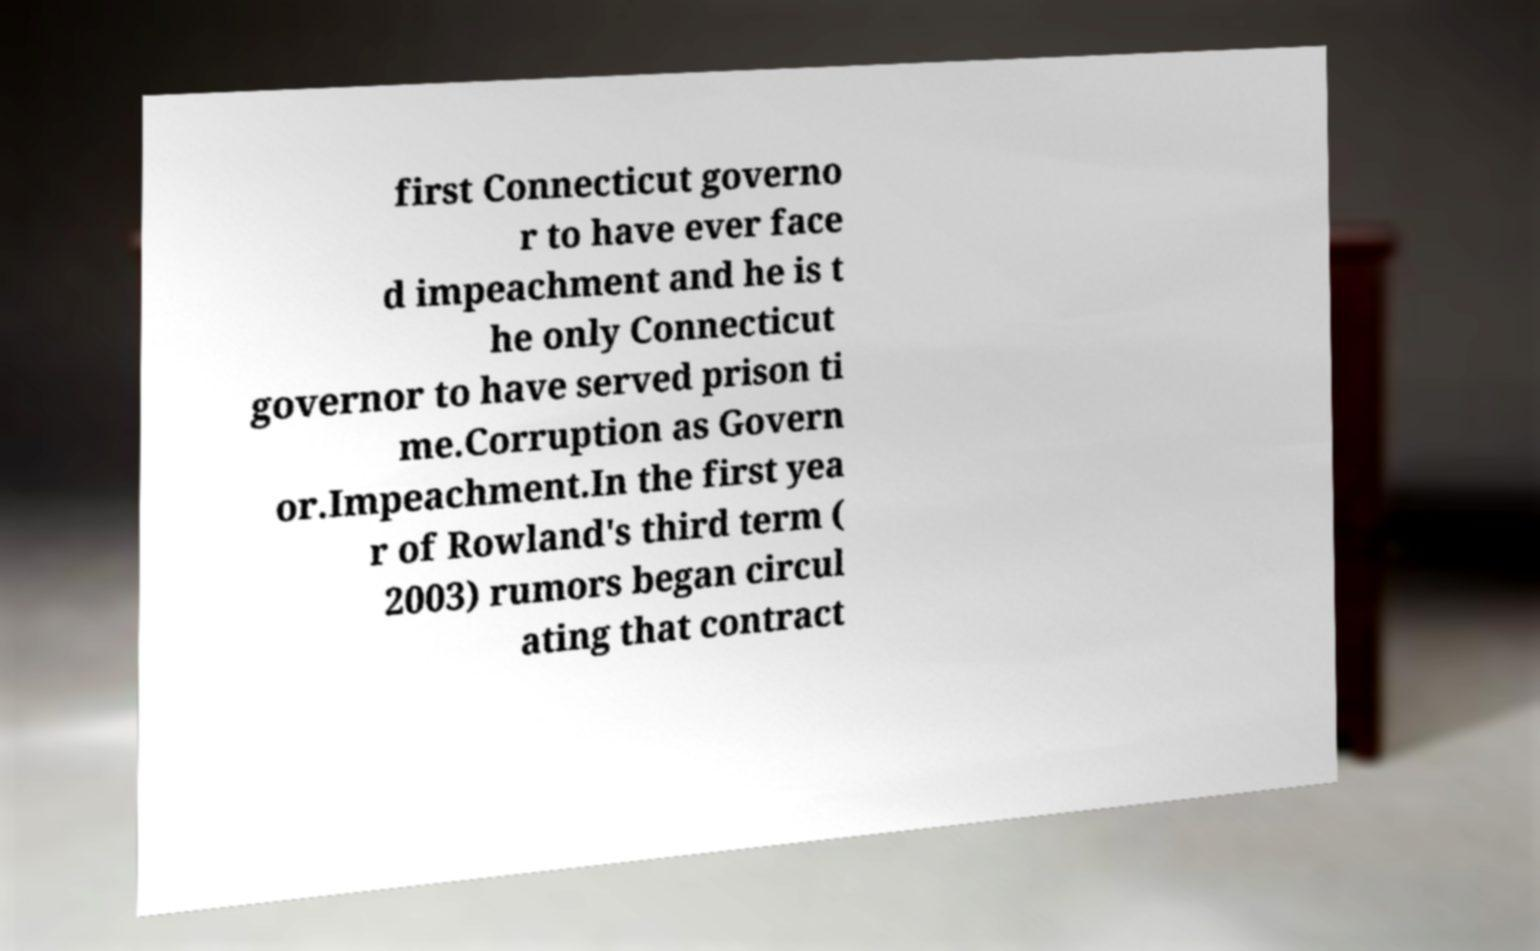For documentation purposes, I need the text within this image transcribed. Could you provide that? first Connecticut governo r to have ever face d impeachment and he is t he only Connecticut governor to have served prison ti me.Corruption as Govern or.Impeachment.In the first yea r of Rowland's third term ( 2003) rumors began circul ating that contract 